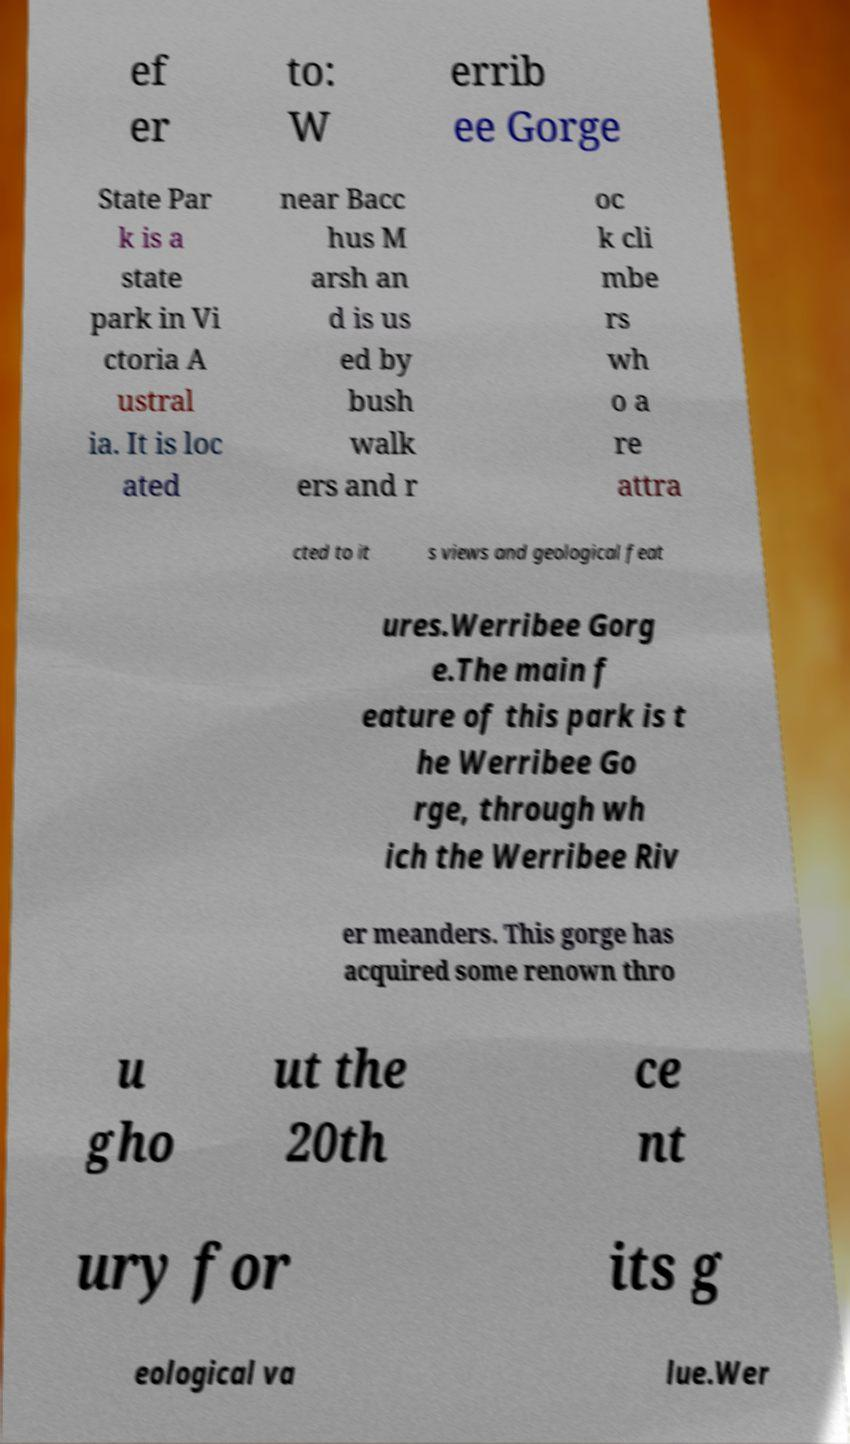I need the written content from this picture converted into text. Can you do that? ef er to: W errib ee Gorge State Par k is a state park in Vi ctoria A ustral ia. It is loc ated near Bacc hus M arsh an d is us ed by bush walk ers and r oc k cli mbe rs wh o a re attra cted to it s views and geological feat ures.Werribee Gorg e.The main f eature of this park is t he Werribee Go rge, through wh ich the Werribee Riv er meanders. This gorge has acquired some renown thro u gho ut the 20th ce nt ury for its g eological va lue.Wer 